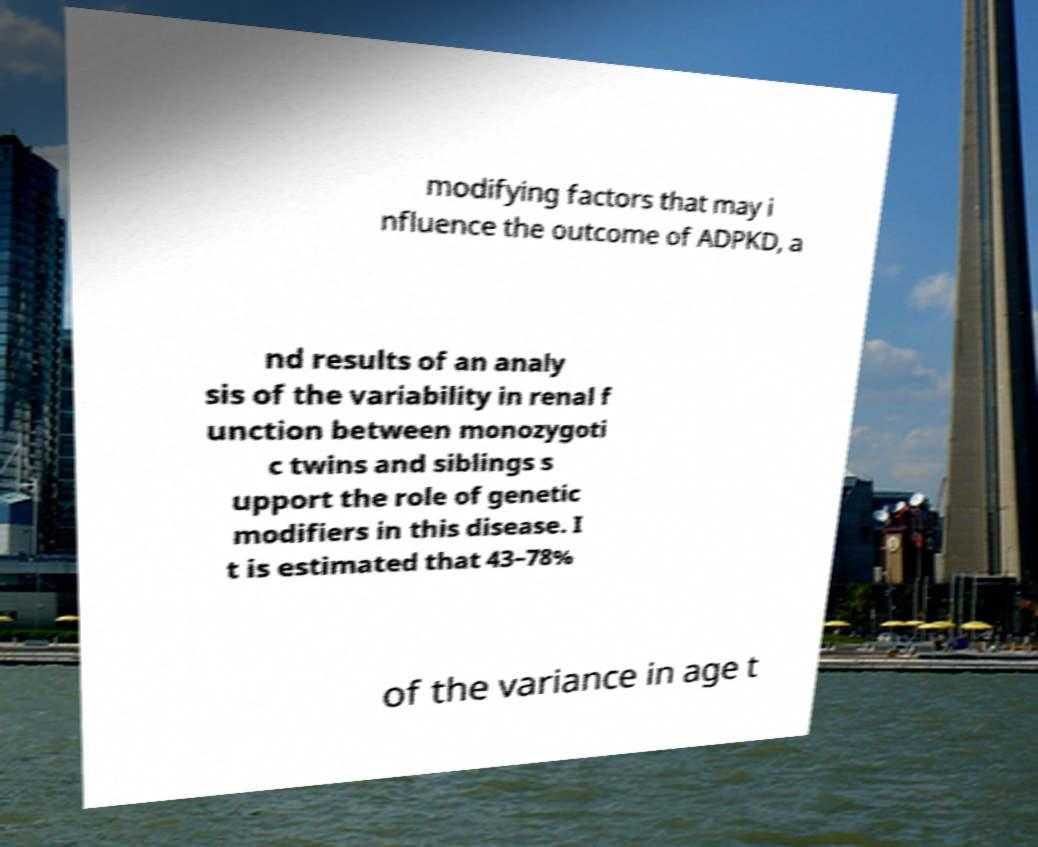Could you extract and type out the text from this image? modifying factors that may i nfluence the outcome of ADPKD, a nd results of an analy sis of the variability in renal f unction between monozygoti c twins and siblings s upport the role of genetic modifiers in this disease. I t is estimated that 43–78% of the variance in age t 